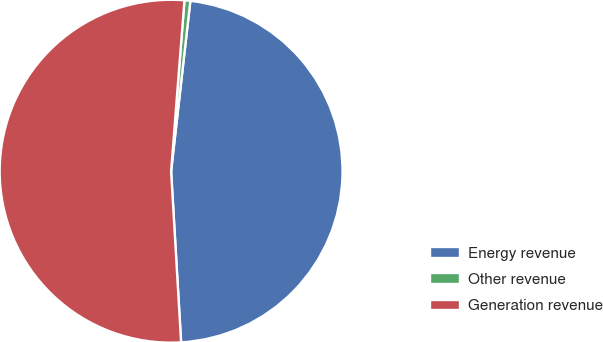Convert chart to OTSL. <chart><loc_0><loc_0><loc_500><loc_500><pie_chart><fcel>Energy revenue<fcel>Other revenue<fcel>Generation revenue<nl><fcel>47.28%<fcel>0.55%<fcel>52.17%<nl></chart> 